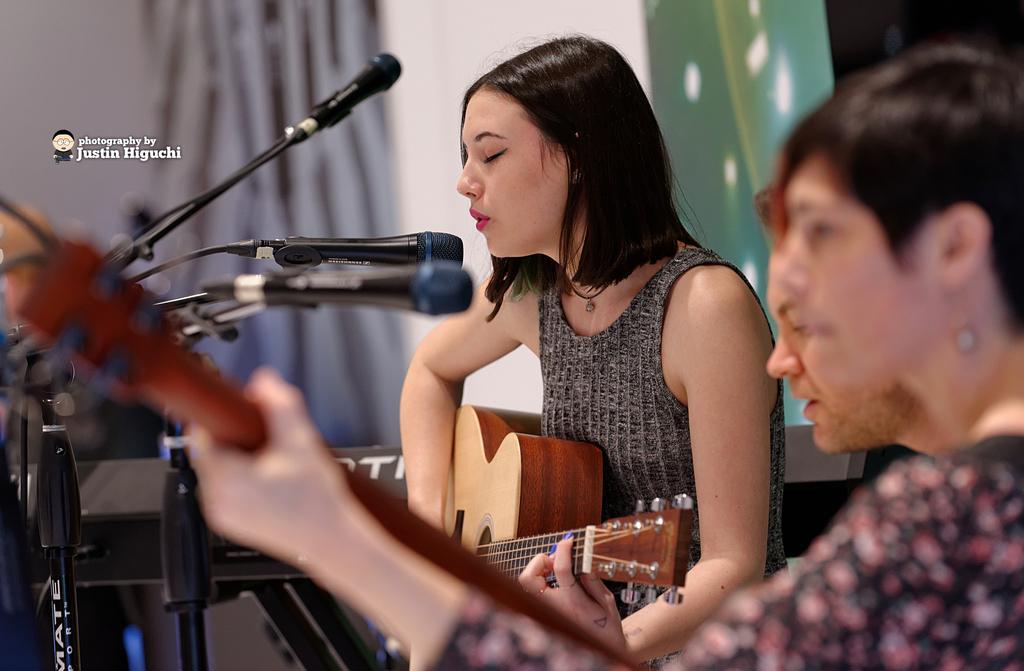In one or two sentences, can you explain what this image depicts? In this image in the middle there is a woman she wear black dress she is playing guitar and singing in mic, her hair is short. On the right there are two people. On the left there are many mics. 